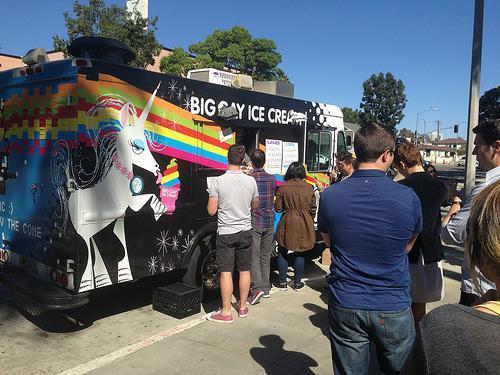How many people are beside the truck?
Give a very brief answer. 3. 